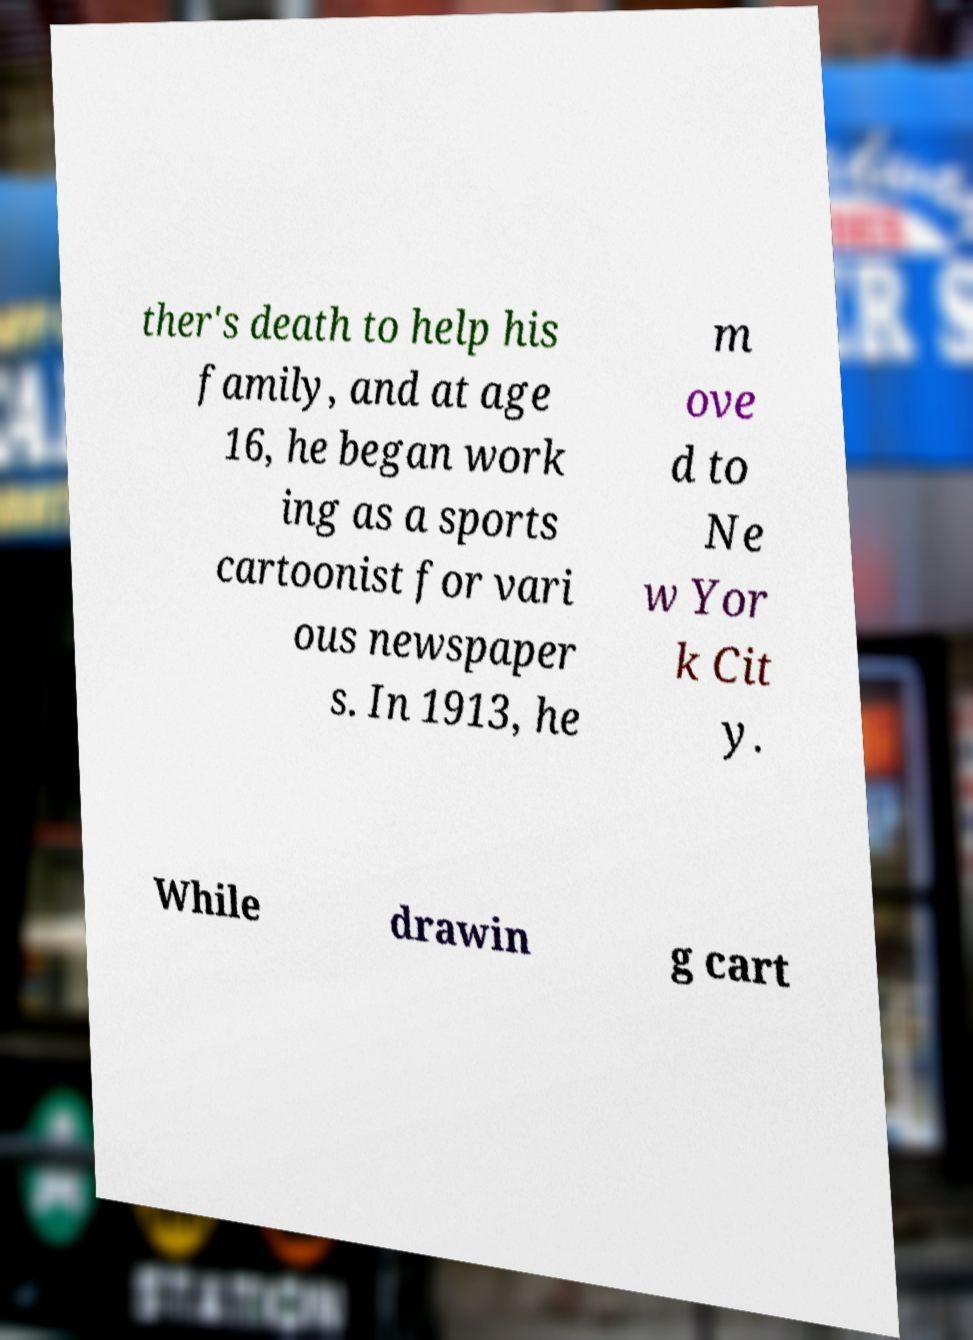Could you assist in decoding the text presented in this image and type it out clearly? ther's death to help his family, and at age 16, he began work ing as a sports cartoonist for vari ous newspaper s. In 1913, he m ove d to Ne w Yor k Cit y. While drawin g cart 